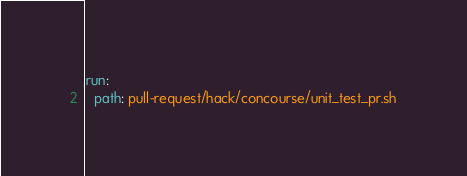Convert code to text. <code><loc_0><loc_0><loc_500><loc_500><_YAML_>
run:
  path: pull-request/hack/concourse/unit_test_pr.sh
</code> 